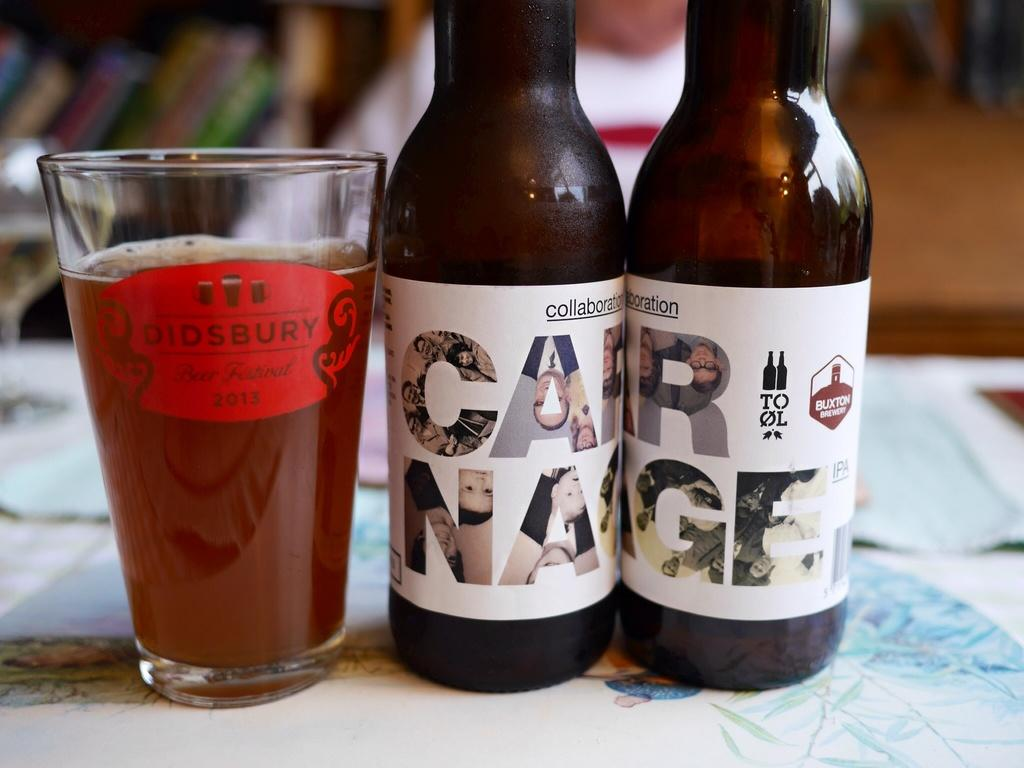Provide a one-sentence caption for the provided image. a didsbury glass  lined up with two ottles of car nage beer. 